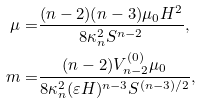<formula> <loc_0><loc_0><loc_500><loc_500>\mu = & \frac { ( n - 2 ) ( n - 3 ) \mu _ { 0 } H ^ { 2 } } { 8 \kappa _ { n } ^ { 2 } S ^ { n - 2 } } , \\ m = & \frac { ( n - 2 ) V _ { n - 2 } ^ { ( 0 ) } \mu _ { 0 } } { 8 \kappa _ { n } ^ { 2 } ( \varepsilon H ) ^ { n - 3 } S ^ { ( n - 3 ) / 2 } } ,</formula> 